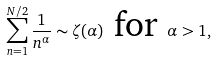Convert formula to latex. <formula><loc_0><loc_0><loc_500><loc_500>\sum _ { n = 1 } ^ { N / 2 } \frac { 1 } { n ^ { \alpha } } \sim \zeta ( \alpha ) \text { for } \alpha > 1 ,</formula> 